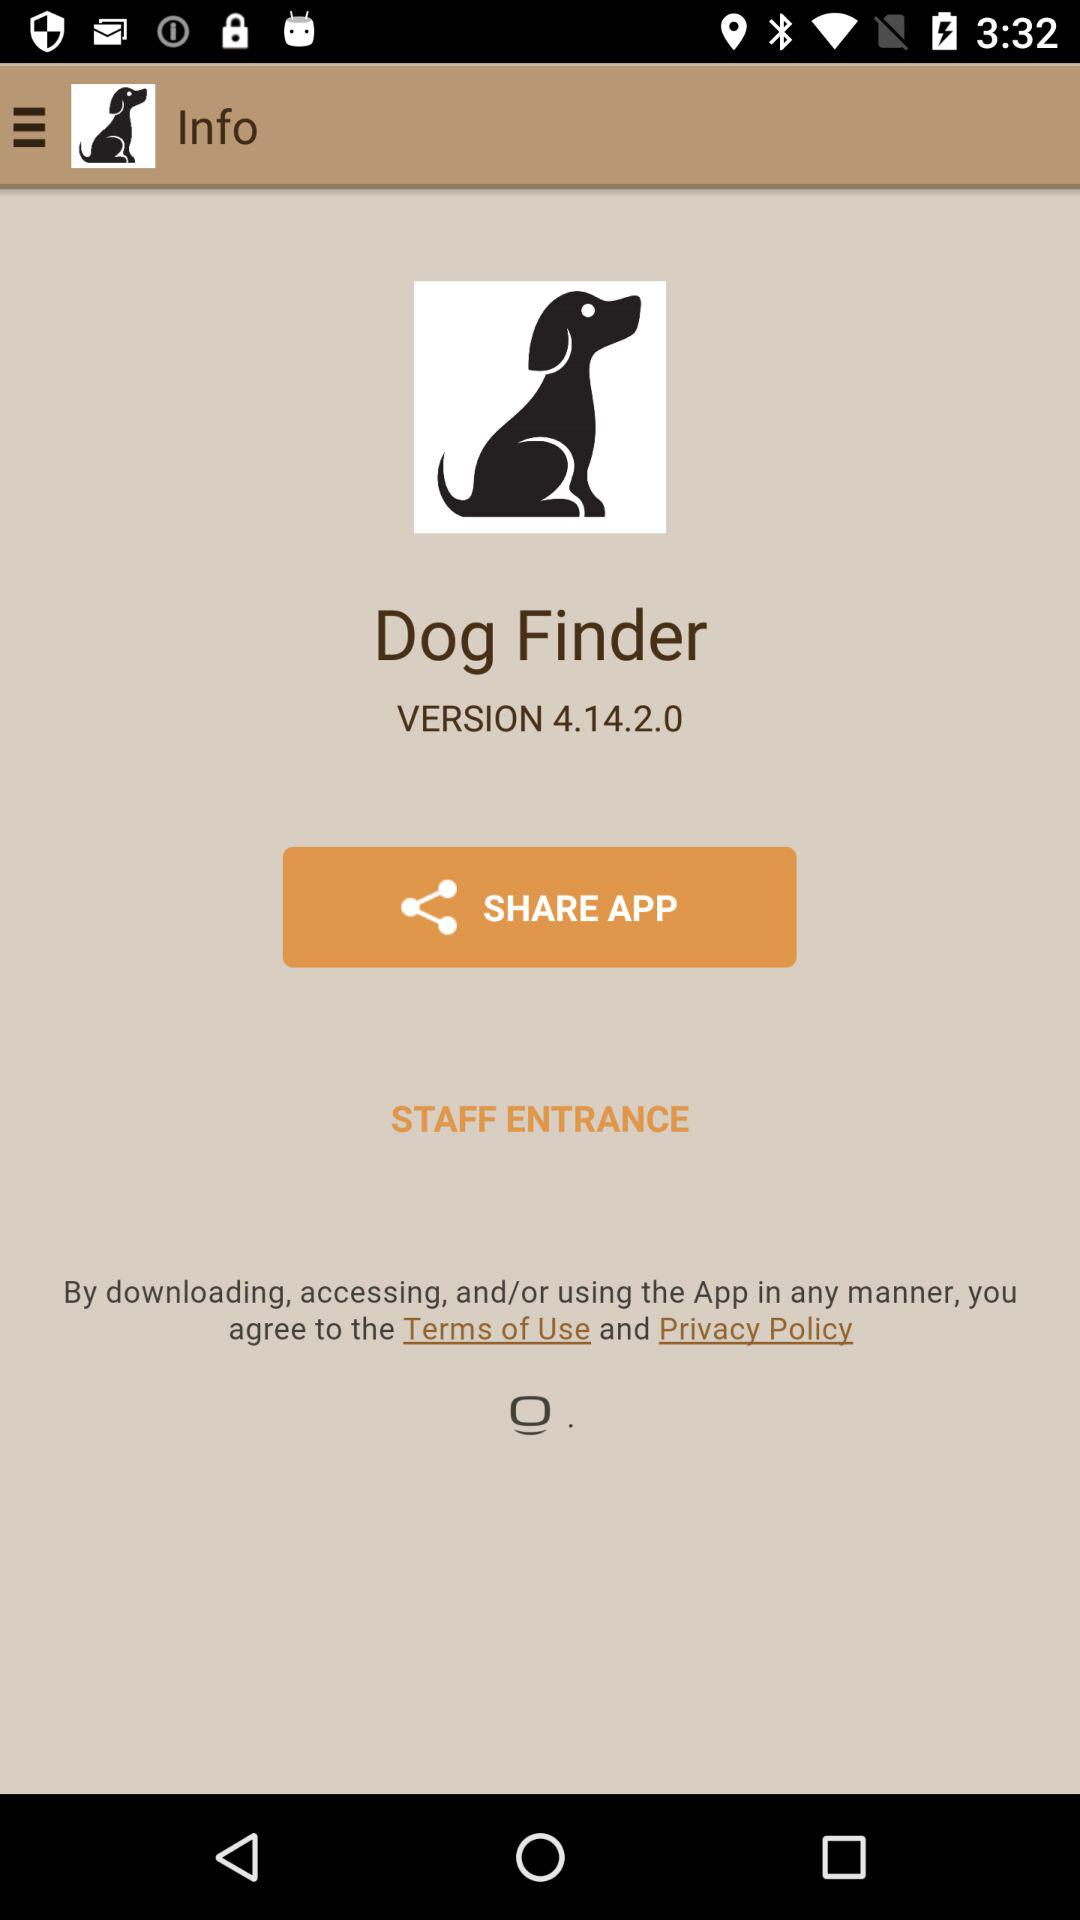What is the name of the application? The name of the application is "Dog Finder". 